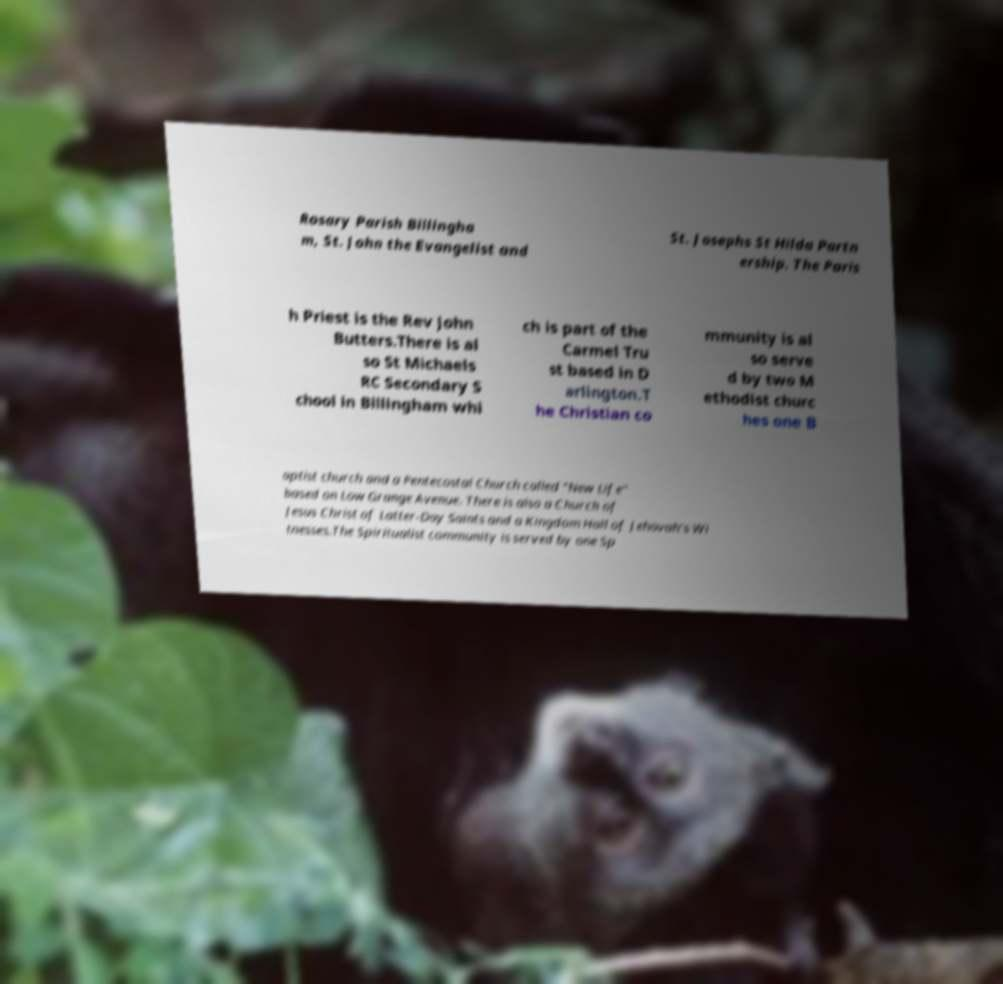For documentation purposes, I need the text within this image transcribed. Could you provide that? Rosary Parish Billingha m, St. John the Evangelist and St. Josephs St Hilda Partn ership. The Paris h Priest is the Rev John Butters.There is al so St Michaels RC Secondary S chool in Billingham whi ch is part of the Carmel Tru st based in D arlington.T he Christian co mmunity is al so serve d by two M ethodist churc hes one B aptist church and a Pentecostal Church called "New Life" based on Low Grange Avenue. There is also a Church of Jesus Christ of Latter-Day Saints and a Kingdom Hall of Jehovah's Wi tnesses.The Spiritualist community is served by one Sp 